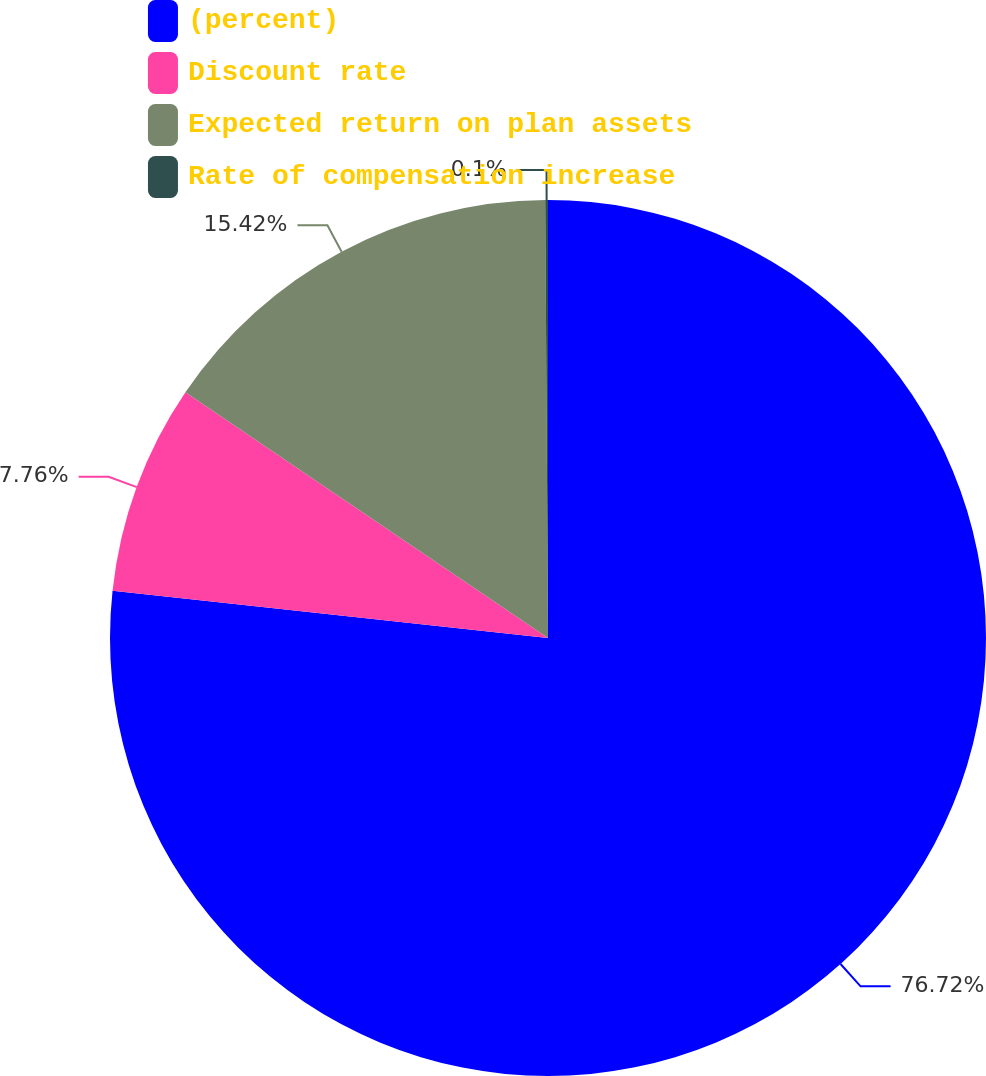Convert chart to OTSL. <chart><loc_0><loc_0><loc_500><loc_500><pie_chart><fcel>(percent)<fcel>Discount rate<fcel>Expected return on plan assets<fcel>Rate of compensation increase<nl><fcel>76.71%<fcel>7.76%<fcel>15.42%<fcel>0.1%<nl></chart> 